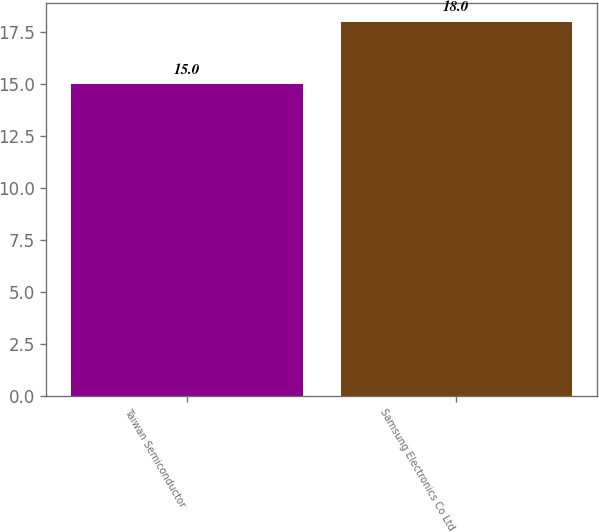Convert chart. <chart><loc_0><loc_0><loc_500><loc_500><bar_chart><fcel>Taiwan Semiconductor<fcel>Samsung Electronics Co Ltd<nl><fcel>15<fcel>18<nl></chart> 